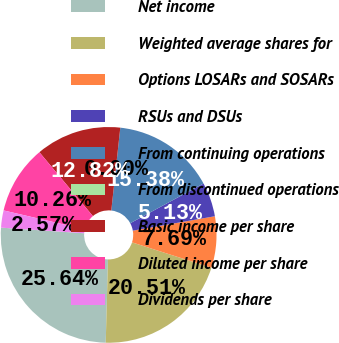Convert chart to OTSL. <chart><loc_0><loc_0><loc_500><loc_500><pie_chart><fcel>Net income<fcel>Weighted average shares for<fcel>Options LOSARs and SOSARs<fcel>RSUs and DSUs<fcel>From continuing operations<fcel>From discontinued operations<fcel>Basic income per share<fcel>Diluted income per share<fcel>Dividends per share<nl><fcel>25.64%<fcel>20.51%<fcel>7.69%<fcel>5.13%<fcel>15.38%<fcel>0.0%<fcel>12.82%<fcel>10.26%<fcel>2.57%<nl></chart> 